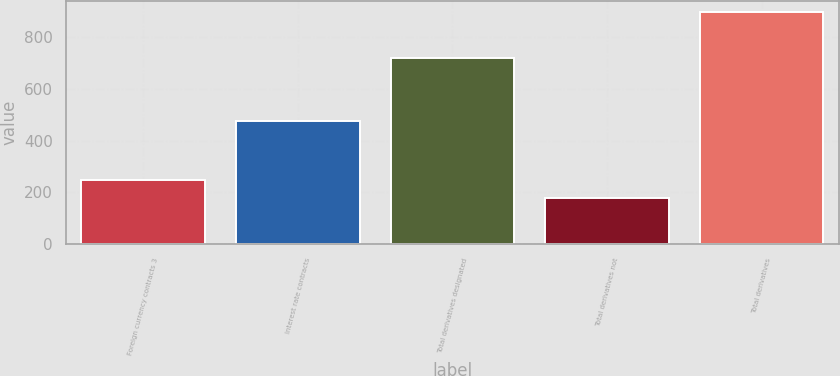<chart> <loc_0><loc_0><loc_500><loc_500><bar_chart><fcel>Foreign currency contracts 3<fcel>Interest rate contracts<fcel>Total derivatives designated<fcel>Total derivatives not<fcel>Total derivatives<nl><fcel>248.8<fcel>474<fcel>718<fcel>177<fcel>895<nl></chart> 